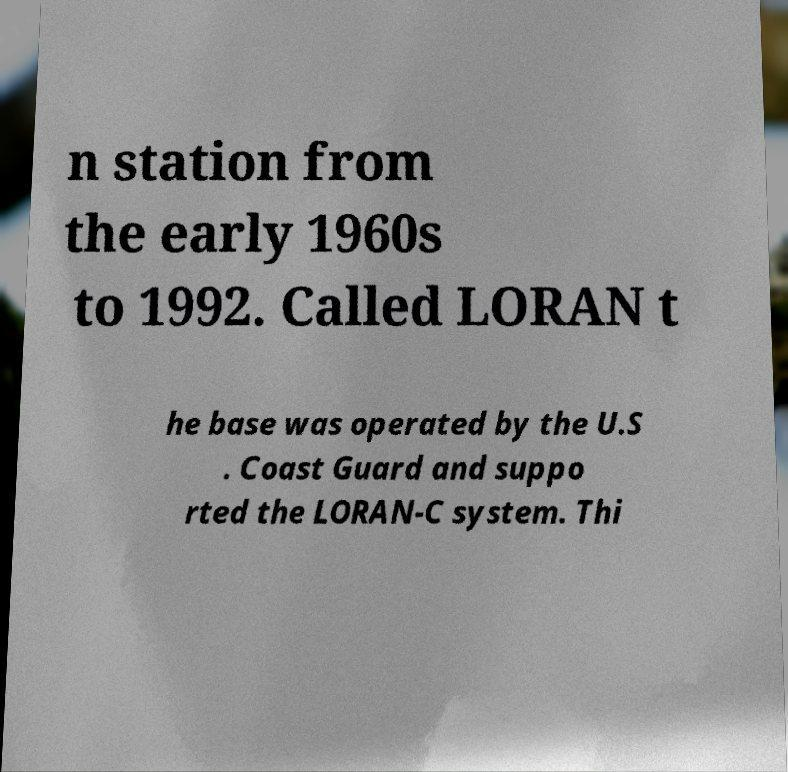I need the written content from this picture converted into text. Can you do that? n station from the early 1960s to 1992. Called LORAN t he base was operated by the U.S . Coast Guard and suppo rted the LORAN-C system. Thi 